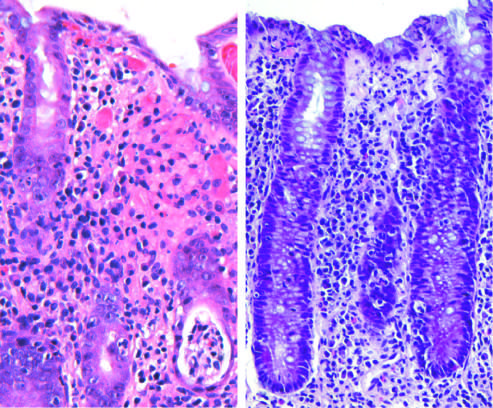what produces acute, self-limited colitis?
Answer the question using a single word or phrase. Campylobacter jejuni infection 